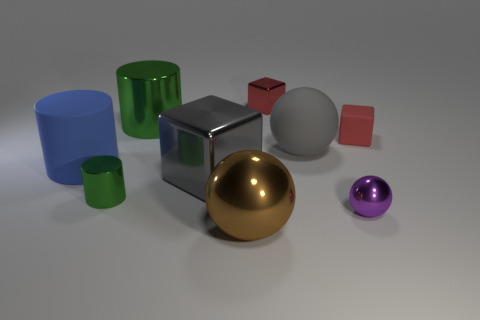Subtract all green cylinders. How many cylinders are left? 1 Subtract all red blocks. How many blocks are left? 1 Add 6 cyan metal objects. How many cyan metal objects exist? 6 Subtract 0 yellow cylinders. How many objects are left? 9 Subtract all cylinders. How many objects are left? 6 Subtract all gray blocks. Subtract all red cylinders. How many blocks are left? 2 Subtract all yellow blocks. How many brown spheres are left? 1 Subtract all large green things. Subtract all small purple metallic objects. How many objects are left? 7 Add 1 small purple objects. How many small purple objects are left? 2 